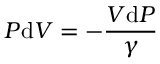Convert formula to latex. <formula><loc_0><loc_0><loc_500><loc_500>P d V = - { \frac { V d P } { \gamma } }</formula> 